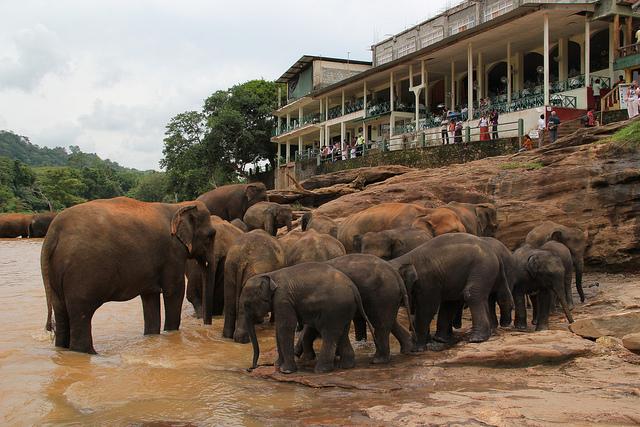What color is the water?
Concise answer only. Brown. How much do all these animal weight?
Give a very brief answer. 10 tons. Are the smaller elephants in danger of sliding down the mud into the water?
Quick response, please. No. What is in the water?
Write a very short answer. Elephants. 